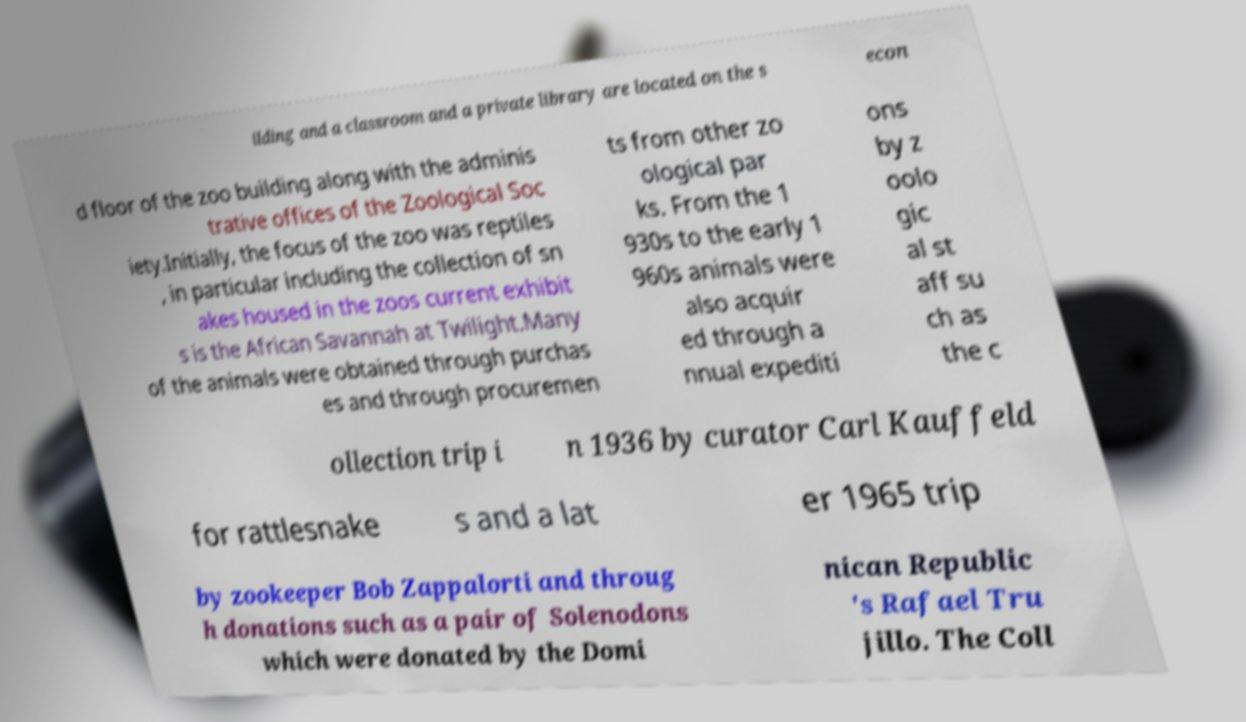Could you assist in decoding the text presented in this image and type it out clearly? ilding and a classroom and a private library are located on the s econ d floor of the zoo building along with the adminis trative offices of the Zoological Soc iety.Initially, the focus of the zoo was reptiles , in particular including the collection of sn akes housed in the zoos current exhibit s is the African Savannah at Twilight.Many of the animals were obtained through purchas es and through procuremen ts from other zo ological par ks. From the 1 930s to the early 1 960s animals were also acquir ed through a nnual expediti ons by z oolo gic al st aff su ch as the c ollection trip i n 1936 by curator Carl Kauffeld for rattlesnake s and a lat er 1965 trip by zookeeper Bob Zappalorti and throug h donations such as a pair of Solenodons which were donated by the Domi nican Republic 's Rafael Tru jillo. The Coll 